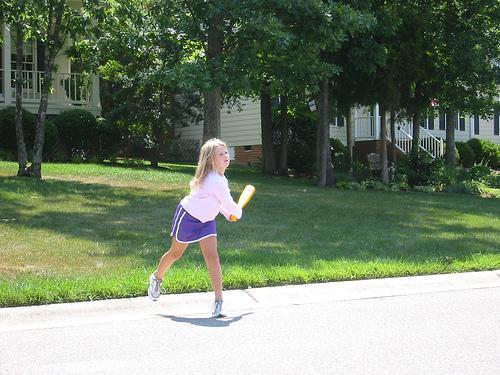How many girls are in the photo?
Give a very brief answer. 1. How many people are pictured?
Give a very brief answer. 1. How many streets are pictured?
Give a very brief answer. 1. How many buses are behind a street sign?
Give a very brief answer. 0. 